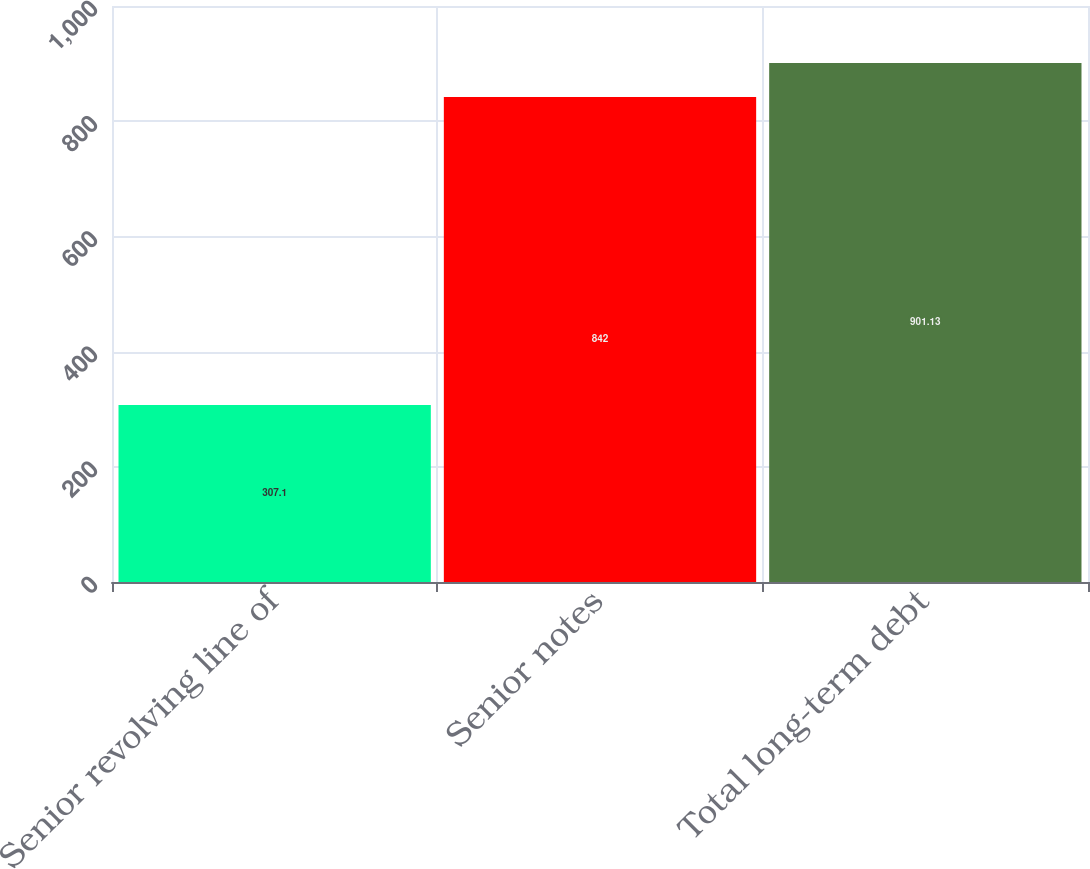<chart> <loc_0><loc_0><loc_500><loc_500><bar_chart><fcel>Senior revolving line of<fcel>Senior notes<fcel>Total long-term debt<nl><fcel>307.1<fcel>842<fcel>901.13<nl></chart> 